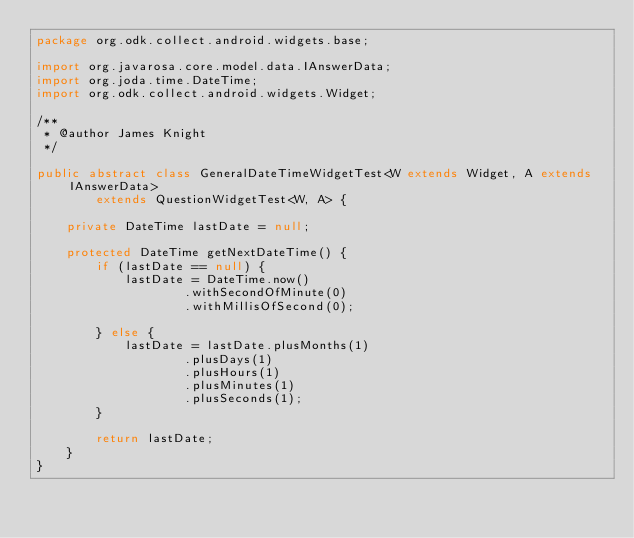Convert code to text. <code><loc_0><loc_0><loc_500><loc_500><_Java_>package org.odk.collect.android.widgets.base;

import org.javarosa.core.model.data.IAnswerData;
import org.joda.time.DateTime;
import org.odk.collect.android.widgets.Widget;

/**
 * @author James Knight
 */

public abstract class GeneralDateTimeWidgetTest<W extends Widget, A extends IAnswerData>
        extends QuestionWidgetTest<W, A> {

    private DateTime lastDate = null;

    protected DateTime getNextDateTime() {
        if (lastDate == null) {
            lastDate = DateTime.now()
                    .withSecondOfMinute(0)
                    .withMillisOfSecond(0);

        } else {
            lastDate = lastDate.plusMonths(1)
                    .plusDays(1)
                    .plusHours(1)
                    .plusMinutes(1)
                    .plusSeconds(1);
        }

        return lastDate;
    }
}
</code> 